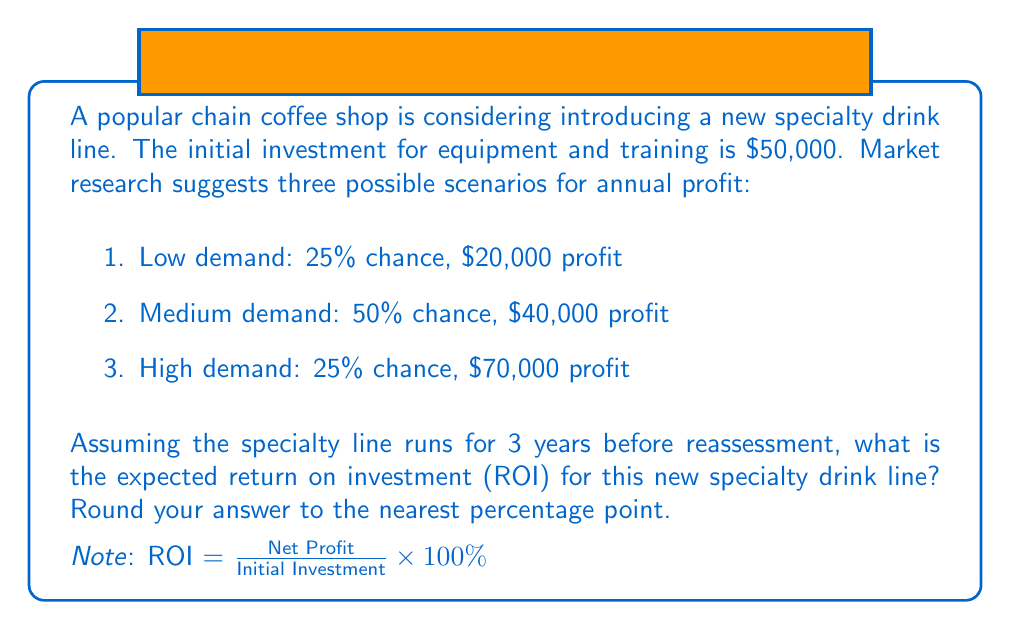Show me your answer to this math problem. Let's approach this step-by-step:

1) First, calculate the expected annual profit:
   $E(\text{Annual Profit}) = 0.25 \times \$20,000 + 0.50 \times \$40,000 + 0.25 \times \$70,000$
   $= \$5,000 + \$20,000 + \$17,500 = \$42,500$

2) Over 3 years, the expected total profit is:
   $E(\text{Total Profit}) = 3 \times \$42,500 = \$127,500$

3) The net profit is the total profit minus the initial investment:
   $\text{Net Profit} = \$127,500 - \$50,000 = \$77,500$

4) Now we can calculate the ROI:
   $$\text{ROI} = \frac{\text{Net Profit}}{\text{Initial Investment}} \times 100\%$$
   $$= \frac{\$77,500}{\$50,000} \times 100\% = 1.55 \times 100\% = 155\%$$

5) Rounding to the nearest percentage point gives us 155%.
Answer: 155% 